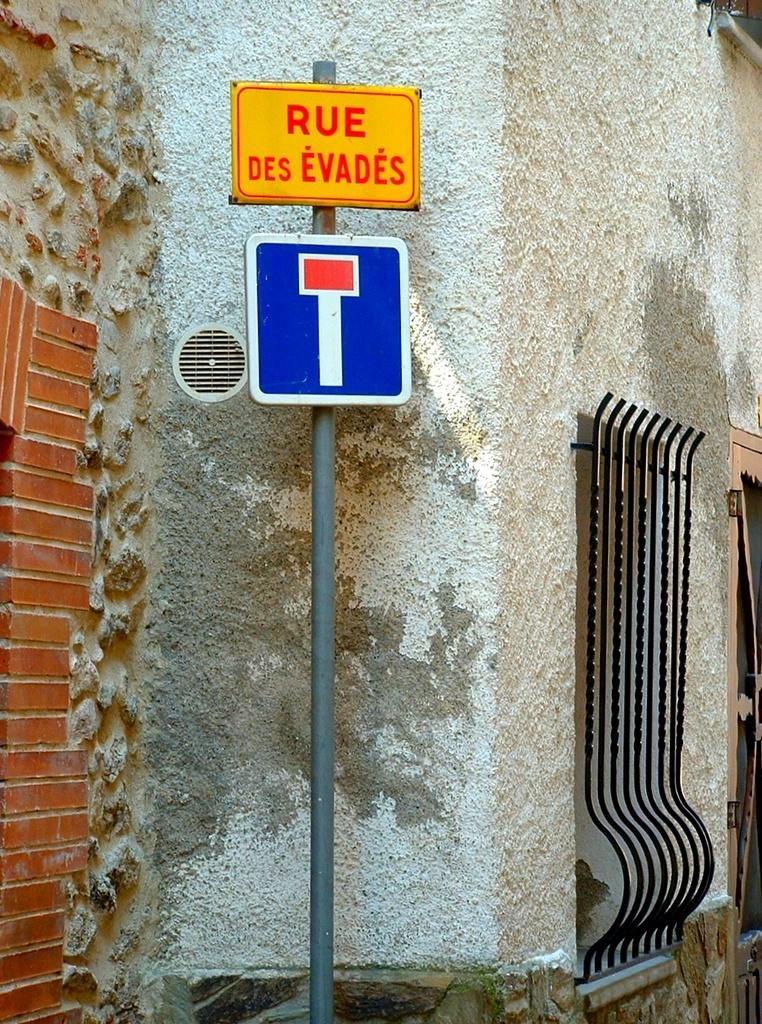<image>
Write a terse but informative summary of the picture. A yellow sign that says Rue Des Evades on it. 